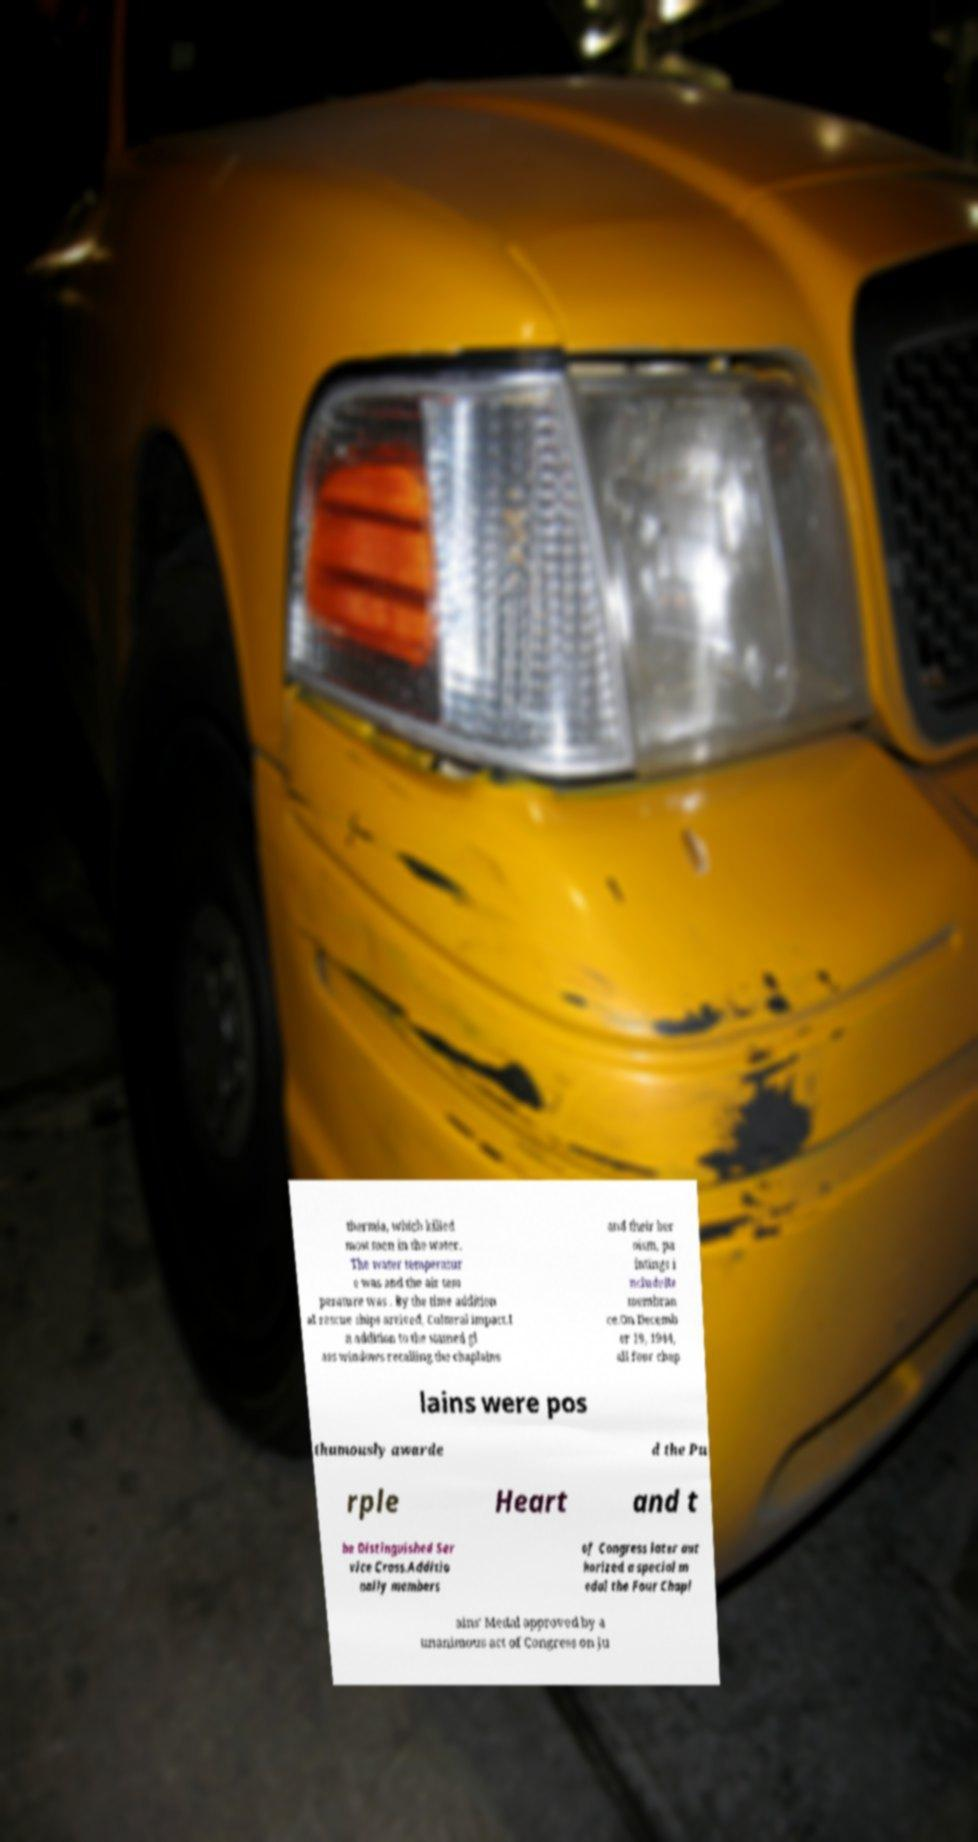Please read and relay the text visible in this image. What does it say? thermia, which killed most men in the water. The water temperatur e was and the air tem perature was . By the time addition al rescue ships arrived, Cultural impact.I n addition to the stained gl ass windows recalling the chaplains and their her oism, pa intings i ncludeRe membran ce.On Decemb er 19, 1944, all four chap lains were pos thumously awarde d the Pu rple Heart and t he Distinguished Ser vice Cross.Additio nally members of Congress later aut horized a special m edal the Four Chapl ains' Medal approved by a unanimous act of Congress on Ju 